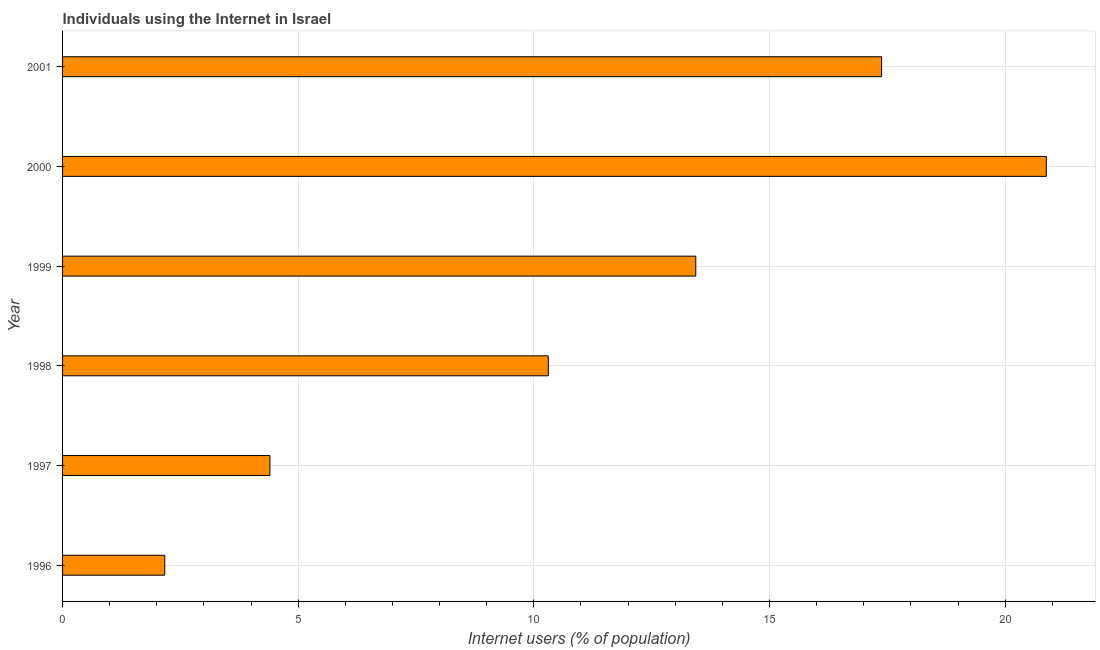Does the graph contain grids?
Keep it short and to the point. Yes. What is the title of the graph?
Your answer should be compact. Individuals using the Internet in Israel. What is the label or title of the X-axis?
Provide a short and direct response. Internet users (% of population). What is the number of internet users in 1996?
Your response must be concise. 2.17. Across all years, what is the maximum number of internet users?
Keep it short and to the point. 20.87. Across all years, what is the minimum number of internet users?
Make the answer very short. 2.17. In which year was the number of internet users maximum?
Make the answer very short. 2000. What is the sum of the number of internet users?
Offer a very short reply. 68.56. What is the difference between the number of internet users in 1996 and 1999?
Ensure brevity in your answer.  -11.27. What is the average number of internet users per year?
Ensure brevity in your answer.  11.43. What is the median number of internet users?
Keep it short and to the point. 11.87. Do a majority of the years between 2000 and 1996 (inclusive) have number of internet users greater than 16 %?
Your response must be concise. Yes. What is the ratio of the number of internet users in 1998 to that in 2001?
Offer a very short reply. 0.59. Is the number of internet users in 1997 less than that in 1998?
Provide a short and direct response. Yes. Is the difference between the number of internet users in 1997 and 1999 greater than the difference between any two years?
Your response must be concise. No. What is the difference between the highest and the second highest number of internet users?
Your answer should be very brief. 3.5. Is the sum of the number of internet users in 1996 and 2000 greater than the maximum number of internet users across all years?
Provide a succinct answer. Yes. What is the difference between the highest and the lowest number of internet users?
Ensure brevity in your answer.  18.71. How many bars are there?
Your response must be concise. 6. Are all the bars in the graph horizontal?
Your answer should be compact. Yes. What is the Internet users (% of population) of 1996?
Offer a terse response. 2.17. What is the Internet users (% of population) in 1997?
Your answer should be compact. 4.4. What is the Internet users (% of population) in 1998?
Offer a very short reply. 10.31. What is the Internet users (% of population) in 1999?
Your answer should be very brief. 13.44. What is the Internet users (% of population) of 2000?
Offer a terse response. 20.87. What is the Internet users (% of population) in 2001?
Make the answer very short. 17.38. What is the difference between the Internet users (% of population) in 1996 and 1997?
Offer a terse response. -2.23. What is the difference between the Internet users (% of population) in 1996 and 1998?
Offer a very short reply. -8.14. What is the difference between the Internet users (% of population) in 1996 and 1999?
Provide a short and direct response. -11.27. What is the difference between the Internet users (% of population) in 1996 and 2000?
Offer a terse response. -18.71. What is the difference between the Internet users (% of population) in 1996 and 2001?
Provide a short and direct response. -15.21. What is the difference between the Internet users (% of population) in 1997 and 1998?
Make the answer very short. -5.91. What is the difference between the Internet users (% of population) in 1997 and 1999?
Give a very brief answer. -9.04. What is the difference between the Internet users (% of population) in 1997 and 2000?
Give a very brief answer. -16.47. What is the difference between the Internet users (% of population) in 1997 and 2001?
Ensure brevity in your answer.  -12.98. What is the difference between the Internet users (% of population) in 1998 and 1999?
Provide a short and direct response. -3.13. What is the difference between the Internet users (% of population) in 1998 and 2000?
Provide a short and direct response. -10.57. What is the difference between the Internet users (% of population) in 1998 and 2001?
Ensure brevity in your answer.  -7.07. What is the difference between the Internet users (% of population) in 1999 and 2000?
Your answer should be very brief. -7.44. What is the difference between the Internet users (% of population) in 1999 and 2001?
Your answer should be compact. -3.94. What is the difference between the Internet users (% of population) in 2000 and 2001?
Provide a succinct answer. 3.5. What is the ratio of the Internet users (% of population) in 1996 to that in 1997?
Provide a short and direct response. 0.49. What is the ratio of the Internet users (% of population) in 1996 to that in 1998?
Keep it short and to the point. 0.21. What is the ratio of the Internet users (% of population) in 1996 to that in 1999?
Provide a succinct answer. 0.16. What is the ratio of the Internet users (% of population) in 1996 to that in 2000?
Ensure brevity in your answer.  0.1. What is the ratio of the Internet users (% of population) in 1997 to that in 1998?
Your response must be concise. 0.43. What is the ratio of the Internet users (% of population) in 1997 to that in 1999?
Your response must be concise. 0.33. What is the ratio of the Internet users (% of population) in 1997 to that in 2000?
Provide a short and direct response. 0.21. What is the ratio of the Internet users (% of population) in 1997 to that in 2001?
Provide a succinct answer. 0.25. What is the ratio of the Internet users (% of population) in 1998 to that in 1999?
Your answer should be very brief. 0.77. What is the ratio of the Internet users (% of population) in 1998 to that in 2000?
Make the answer very short. 0.49. What is the ratio of the Internet users (% of population) in 1998 to that in 2001?
Your response must be concise. 0.59. What is the ratio of the Internet users (% of population) in 1999 to that in 2000?
Offer a very short reply. 0.64. What is the ratio of the Internet users (% of population) in 1999 to that in 2001?
Make the answer very short. 0.77. What is the ratio of the Internet users (% of population) in 2000 to that in 2001?
Keep it short and to the point. 1.2. 